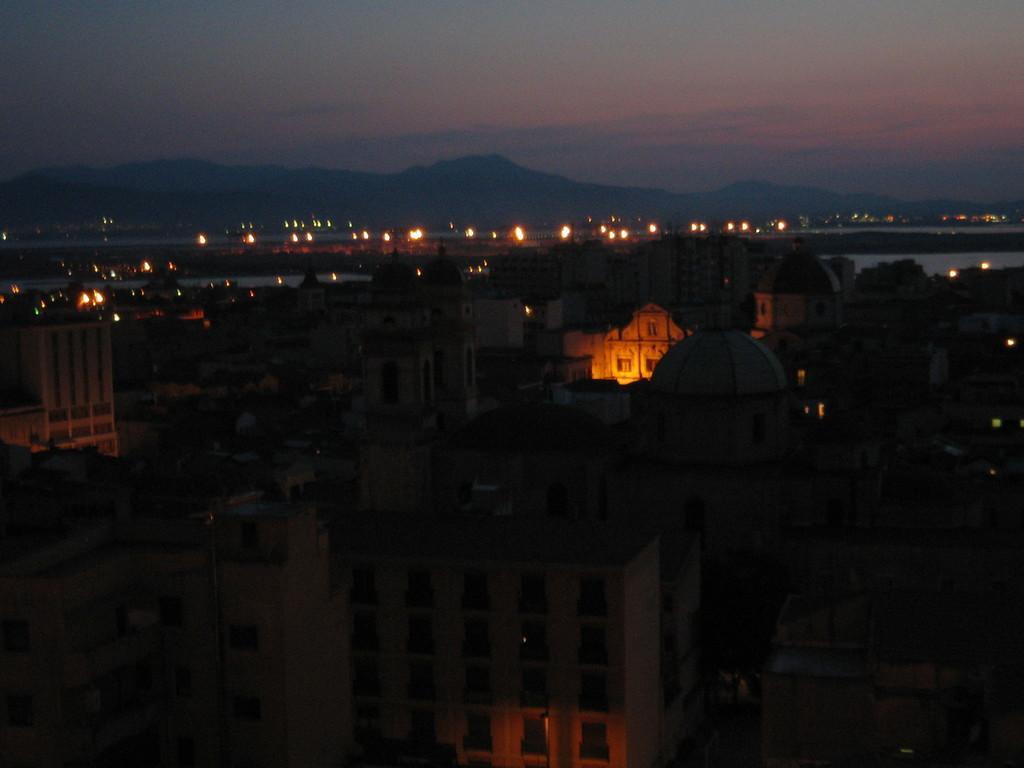Please provide a concise description of this image. In this picture we can see many buildings. In the back we can see lights, water and mountains. At the top we can see sky and clouds. 